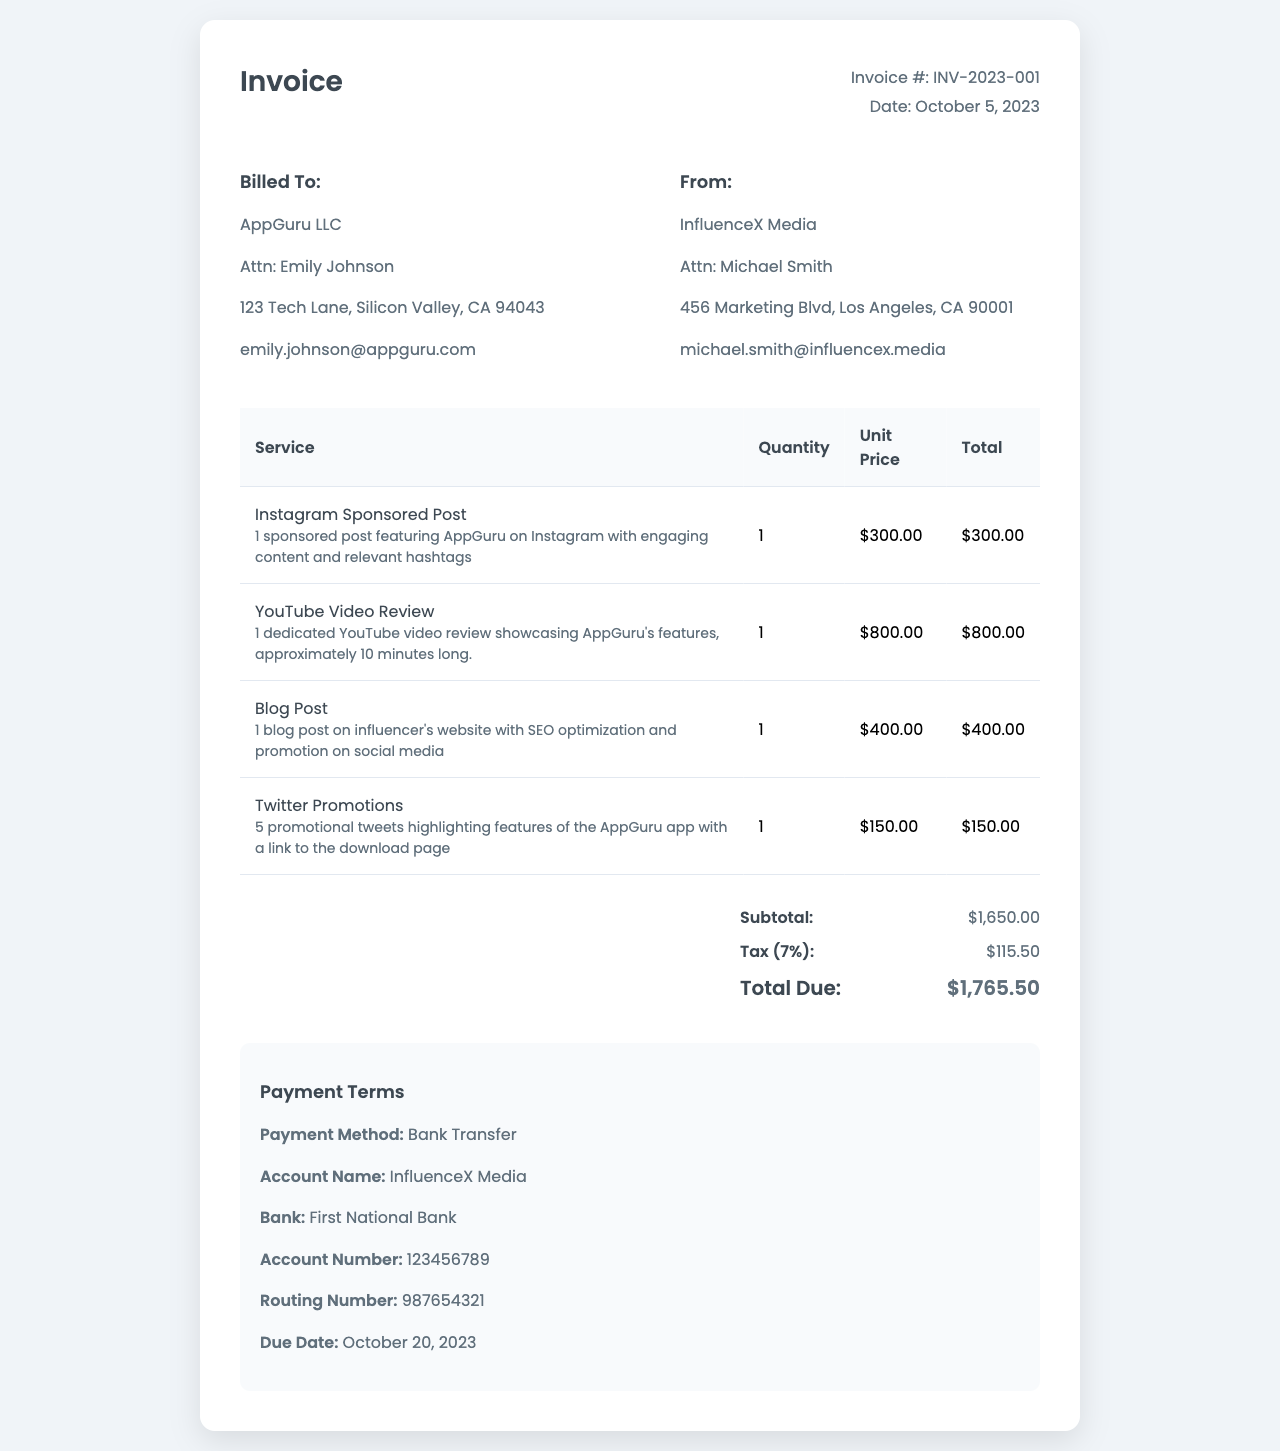What is the invoice number? The invoice number is listed at the top of the document under invoice details.
Answer: INV-2023-001 Who is billed for the services? The billing address section indicates who is being billed.
Answer: AppGuru LLC What is the total due amount? The total due is provided in the summary section of the document.
Answer: $1,765.50 How many promotional tweets are included? The service details specify the number of promotional tweets provided.
Answer: 5 What is the due date for payment? The due date is found in the payment terms section of the invoice.
Answer: October 20, 2023 What is the unit price for the Instagram sponsored post? The unit price for the Instagram sponsored post is mentioned in the invoice table under unit price.
Answer: $300.00 Which service has the highest cost? The total amounts of each service are compared to determine which is the highest.
Answer: YouTube Video Review What payment method is specified? The payment terms section details the method of payment expected.
Answer: Bank Transfer 